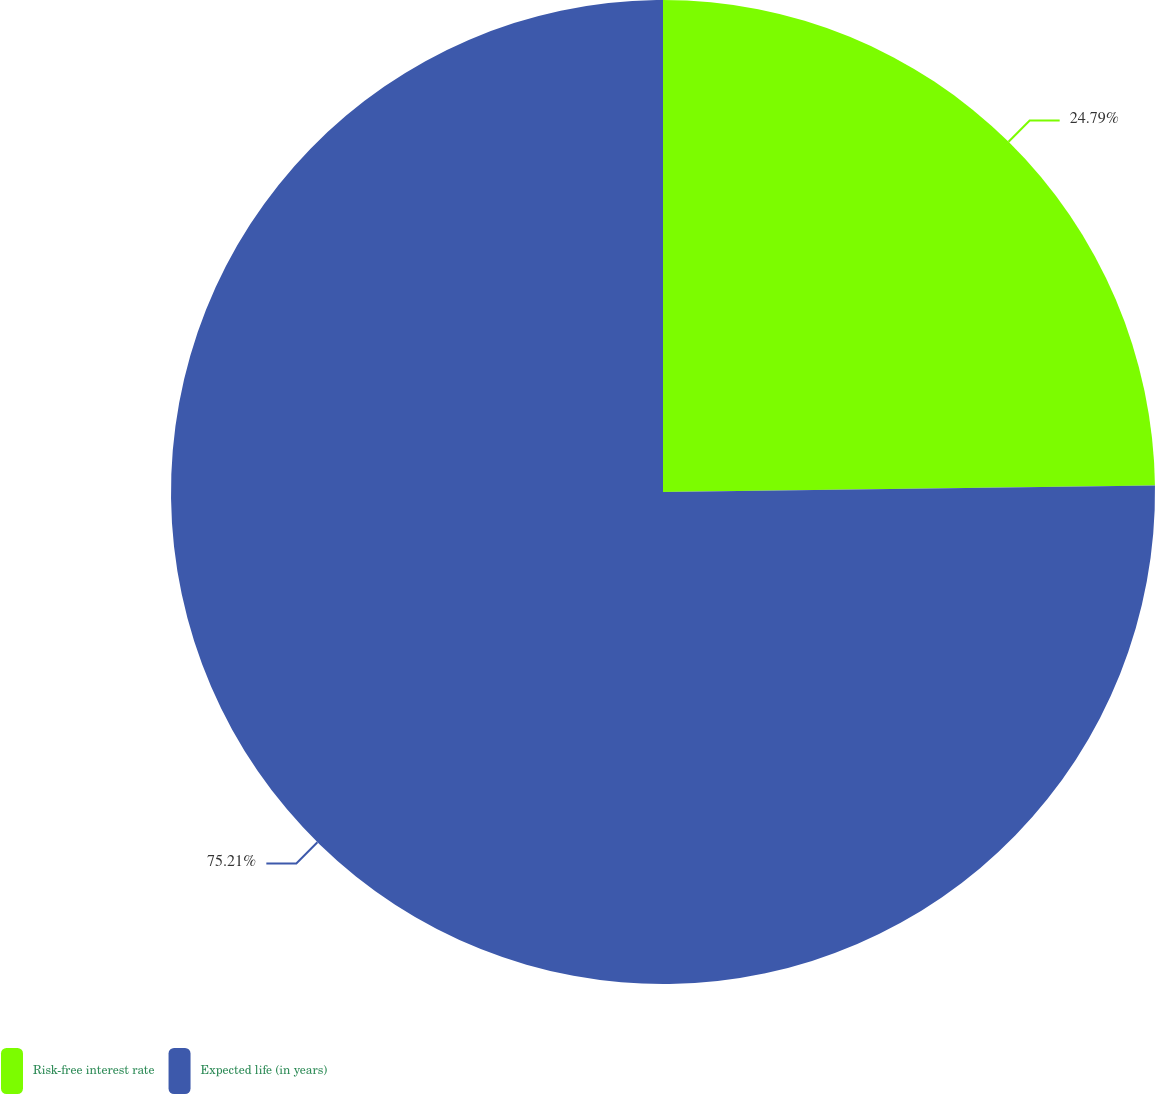<chart> <loc_0><loc_0><loc_500><loc_500><pie_chart><fcel>Risk-free interest rate<fcel>Expected life (in years)<nl><fcel>24.79%<fcel>75.21%<nl></chart> 